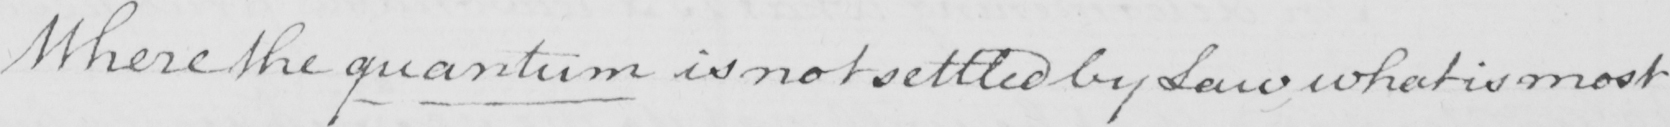What text is written in this handwritten line? Where the quantum is not settled by Law , what is most 